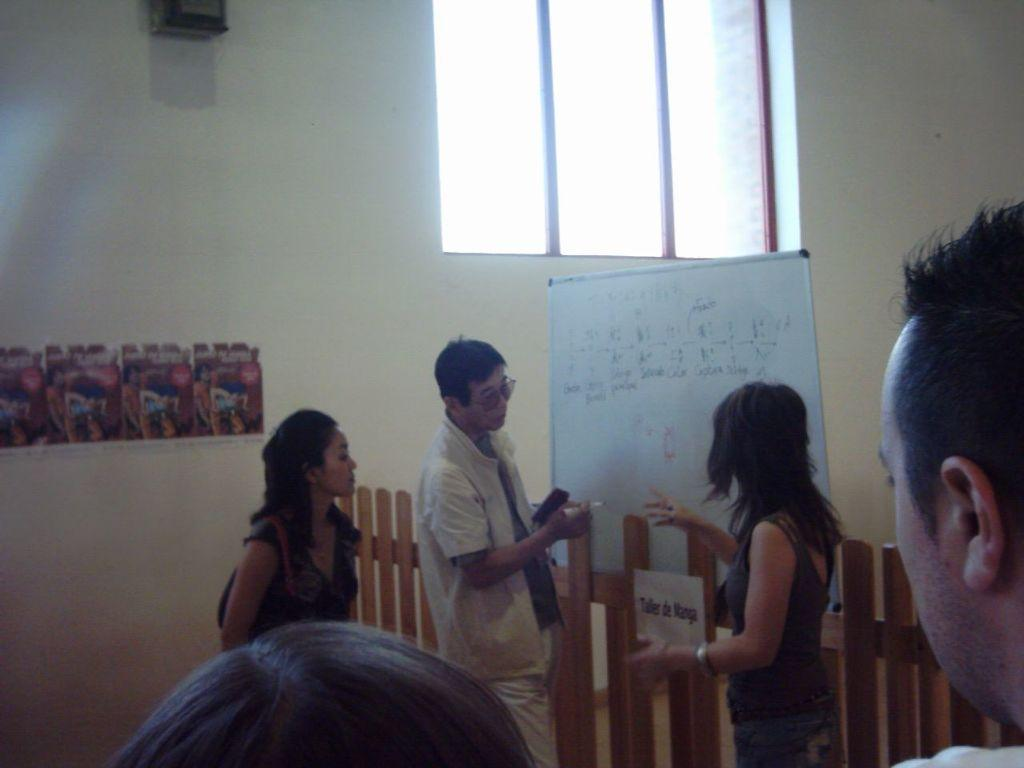Who or what is present in the image? There is a person in the image. What type of structure can be seen in the image? There is a wooden fence in the image. What is the white object in the image? There is a white color board in the image. What architectural feature is visible in the image? There is a window in the image. What decorative elements are attached to the window? There are stickers attached to the window on the left side. How many boys are rolling down the hill in the image? There are no boys or hills present in the image. 